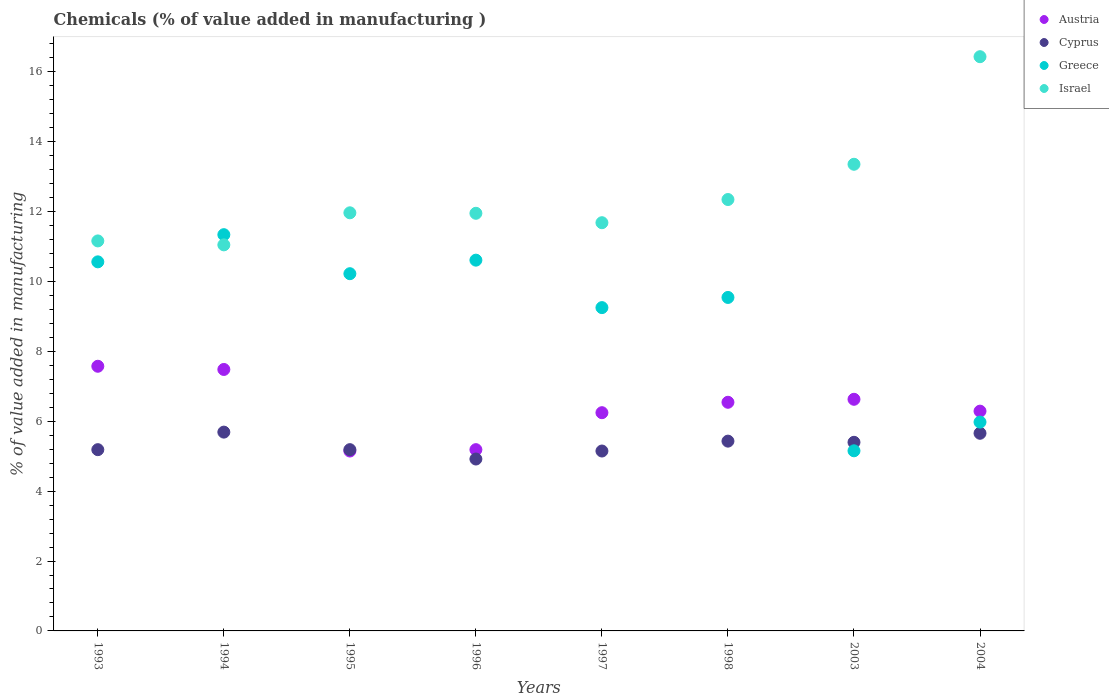How many different coloured dotlines are there?
Provide a succinct answer. 4. Is the number of dotlines equal to the number of legend labels?
Ensure brevity in your answer.  Yes. What is the value added in manufacturing chemicals in Cyprus in 1994?
Give a very brief answer. 5.69. Across all years, what is the maximum value added in manufacturing chemicals in Austria?
Provide a short and direct response. 7.57. Across all years, what is the minimum value added in manufacturing chemicals in Greece?
Your answer should be very brief. 5.16. In which year was the value added in manufacturing chemicals in Austria maximum?
Ensure brevity in your answer.  1993. What is the total value added in manufacturing chemicals in Austria in the graph?
Your answer should be very brief. 51.1. What is the difference between the value added in manufacturing chemicals in Cyprus in 1995 and that in 1998?
Ensure brevity in your answer.  -0.24. What is the difference between the value added in manufacturing chemicals in Austria in 1995 and the value added in manufacturing chemicals in Greece in 1997?
Your response must be concise. -4.1. What is the average value added in manufacturing chemicals in Austria per year?
Your answer should be compact. 6.39. In the year 1995, what is the difference between the value added in manufacturing chemicals in Cyprus and value added in manufacturing chemicals in Greece?
Your answer should be compact. -5.04. What is the ratio of the value added in manufacturing chemicals in Greece in 1997 to that in 2004?
Give a very brief answer. 1.55. Is the difference between the value added in manufacturing chemicals in Cyprus in 1998 and 2003 greater than the difference between the value added in manufacturing chemicals in Greece in 1998 and 2003?
Ensure brevity in your answer.  No. What is the difference between the highest and the second highest value added in manufacturing chemicals in Cyprus?
Ensure brevity in your answer.  0.03. What is the difference between the highest and the lowest value added in manufacturing chemicals in Israel?
Make the answer very short. 5.39. Is the sum of the value added in manufacturing chemicals in Israel in 1995 and 1998 greater than the maximum value added in manufacturing chemicals in Austria across all years?
Provide a succinct answer. Yes. Is it the case that in every year, the sum of the value added in manufacturing chemicals in Israel and value added in manufacturing chemicals in Cyprus  is greater than the value added in manufacturing chemicals in Austria?
Provide a succinct answer. Yes. Does the value added in manufacturing chemicals in Greece monotonically increase over the years?
Ensure brevity in your answer.  No. How many dotlines are there?
Provide a short and direct response. 4. How many years are there in the graph?
Give a very brief answer. 8. Does the graph contain any zero values?
Keep it short and to the point. No. Does the graph contain grids?
Make the answer very short. No. How many legend labels are there?
Make the answer very short. 4. What is the title of the graph?
Give a very brief answer. Chemicals (% of value added in manufacturing ). What is the label or title of the X-axis?
Give a very brief answer. Years. What is the label or title of the Y-axis?
Keep it short and to the point. % of value added in manufacturing. What is the % of value added in manufacturing in Austria in 1993?
Ensure brevity in your answer.  7.57. What is the % of value added in manufacturing in Cyprus in 1993?
Your answer should be very brief. 5.19. What is the % of value added in manufacturing in Greece in 1993?
Provide a succinct answer. 10.56. What is the % of value added in manufacturing of Israel in 1993?
Your answer should be compact. 11.16. What is the % of value added in manufacturing in Austria in 1994?
Your answer should be very brief. 7.48. What is the % of value added in manufacturing of Cyprus in 1994?
Offer a very short reply. 5.69. What is the % of value added in manufacturing in Greece in 1994?
Provide a succinct answer. 11.34. What is the % of value added in manufacturing of Israel in 1994?
Your answer should be compact. 11.05. What is the % of value added in manufacturing of Austria in 1995?
Make the answer very short. 5.15. What is the % of value added in manufacturing in Cyprus in 1995?
Offer a terse response. 5.19. What is the % of value added in manufacturing in Greece in 1995?
Keep it short and to the point. 10.22. What is the % of value added in manufacturing of Israel in 1995?
Keep it short and to the point. 11.97. What is the % of value added in manufacturing in Austria in 1996?
Your answer should be very brief. 5.19. What is the % of value added in manufacturing in Cyprus in 1996?
Provide a succinct answer. 4.92. What is the % of value added in manufacturing in Greece in 1996?
Ensure brevity in your answer.  10.61. What is the % of value added in manufacturing in Israel in 1996?
Ensure brevity in your answer.  11.95. What is the % of value added in manufacturing in Austria in 1997?
Offer a very short reply. 6.25. What is the % of value added in manufacturing in Cyprus in 1997?
Provide a short and direct response. 5.15. What is the % of value added in manufacturing in Greece in 1997?
Ensure brevity in your answer.  9.25. What is the % of value added in manufacturing in Israel in 1997?
Provide a short and direct response. 11.68. What is the % of value added in manufacturing of Austria in 1998?
Provide a short and direct response. 6.54. What is the % of value added in manufacturing in Cyprus in 1998?
Your response must be concise. 5.43. What is the % of value added in manufacturing of Greece in 1998?
Keep it short and to the point. 9.54. What is the % of value added in manufacturing in Israel in 1998?
Give a very brief answer. 12.35. What is the % of value added in manufacturing of Austria in 2003?
Give a very brief answer. 6.63. What is the % of value added in manufacturing in Cyprus in 2003?
Provide a succinct answer. 5.4. What is the % of value added in manufacturing in Greece in 2003?
Your answer should be compact. 5.16. What is the % of value added in manufacturing of Israel in 2003?
Your answer should be compact. 13.36. What is the % of value added in manufacturing in Austria in 2004?
Your answer should be very brief. 6.29. What is the % of value added in manufacturing of Cyprus in 2004?
Ensure brevity in your answer.  5.66. What is the % of value added in manufacturing of Greece in 2004?
Ensure brevity in your answer.  5.98. What is the % of value added in manufacturing in Israel in 2004?
Keep it short and to the point. 16.43. Across all years, what is the maximum % of value added in manufacturing in Austria?
Keep it short and to the point. 7.57. Across all years, what is the maximum % of value added in manufacturing in Cyprus?
Offer a terse response. 5.69. Across all years, what is the maximum % of value added in manufacturing of Greece?
Your answer should be compact. 11.34. Across all years, what is the maximum % of value added in manufacturing of Israel?
Ensure brevity in your answer.  16.43. Across all years, what is the minimum % of value added in manufacturing in Austria?
Your response must be concise. 5.15. Across all years, what is the minimum % of value added in manufacturing of Cyprus?
Keep it short and to the point. 4.92. Across all years, what is the minimum % of value added in manufacturing of Greece?
Your response must be concise. 5.16. Across all years, what is the minimum % of value added in manufacturing of Israel?
Make the answer very short. 11.05. What is the total % of value added in manufacturing in Austria in the graph?
Ensure brevity in your answer.  51.1. What is the total % of value added in manufacturing of Cyprus in the graph?
Provide a short and direct response. 42.62. What is the total % of value added in manufacturing of Greece in the graph?
Offer a terse response. 72.67. What is the total % of value added in manufacturing of Israel in the graph?
Your answer should be compact. 99.95. What is the difference between the % of value added in manufacturing in Austria in 1993 and that in 1994?
Keep it short and to the point. 0.09. What is the difference between the % of value added in manufacturing of Cyprus in 1993 and that in 1994?
Ensure brevity in your answer.  -0.5. What is the difference between the % of value added in manufacturing in Greece in 1993 and that in 1994?
Keep it short and to the point. -0.78. What is the difference between the % of value added in manufacturing of Israel in 1993 and that in 1994?
Make the answer very short. 0.11. What is the difference between the % of value added in manufacturing of Austria in 1993 and that in 1995?
Give a very brief answer. 2.43. What is the difference between the % of value added in manufacturing of Cyprus in 1993 and that in 1995?
Offer a very short reply. -0. What is the difference between the % of value added in manufacturing of Greece in 1993 and that in 1995?
Provide a short and direct response. 0.34. What is the difference between the % of value added in manufacturing of Israel in 1993 and that in 1995?
Offer a terse response. -0.8. What is the difference between the % of value added in manufacturing of Austria in 1993 and that in 1996?
Ensure brevity in your answer.  2.39. What is the difference between the % of value added in manufacturing in Cyprus in 1993 and that in 1996?
Provide a succinct answer. 0.27. What is the difference between the % of value added in manufacturing of Greece in 1993 and that in 1996?
Offer a very short reply. -0.05. What is the difference between the % of value added in manufacturing in Israel in 1993 and that in 1996?
Keep it short and to the point. -0.79. What is the difference between the % of value added in manufacturing of Austria in 1993 and that in 1997?
Offer a very short reply. 1.33. What is the difference between the % of value added in manufacturing in Cyprus in 1993 and that in 1997?
Your answer should be very brief. 0.04. What is the difference between the % of value added in manufacturing of Greece in 1993 and that in 1997?
Keep it short and to the point. 1.31. What is the difference between the % of value added in manufacturing in Israel in 1993 and that in 1997?
Make the answer very short. -0.52. What is the difference between the % of value added in manufacturing of Austria in 1993 and that in 1998?
Your answer should be compact. 1.03. What is the difference between the % of value added in manufacturing of Cyprus in 1993 and that in 1998?
Provide a succinct answer. -0.24. What is the difference between the % of value added in manufacturing of Greece in 1993 and that in 1998?
Give a very brief answer. 1.02. What is the difference between the % of value added in manufacturing in Israel in 1993 and that in 1998?
Your answer should be compact. -1.18. What is the difference between the % of value added in manufacturing in Austria in 1993 and that in 2003?
Your answer should be very brief. 0.95. What is the difference between the % of value added in manufacturing of Cyprus in 1993 and that in 2003?
Make the answer very short. -0.21. What is the difference between the % of value added in manufacturing in Greece in 1993 and that in 2003?
Your response must be concise. 5.41. What is the difference between the % of value added in manufacturing in Israel in 1993 and that in 2003?
Your response must be concise. -2.19. What is the difference between the % of value added in manufacturing in Austria in 1993 and that in 2004?
Provide a short and direct response. 1.28. What is the difference between the % of value added in manufacturing in Cyprus in 1993 and that in 2004?
Make the answer very short. -0.47. What is the difference between the % of value added in manufacturing in Greece in 1993 and that in 2004?
Offer a terse response. 4.59. What is the difference between the % of value added in manufacturing of Israel in 1993 and that in 2004?
Ensure brevity in your answer.  -5.27. What is the difference between the % of value added in manufacturing of Austria in 1994 and that in 1995?
Provide a succinct answer. 2.33. What is the difference between the % of value added in manufacturing in Cyprus in 1994 and that in 1995?
Provide a short and direct response. 0.5. What is the difference between the % of value added in manufacturing of Greece in 1994 and that in 1995?
Your response must be concise. 1.12. What is the difference between the % of value added in manufacturing of Israel in 1994 and that in 1995?
Make the answer very short. -0.92. What is the difference between the % of value added in manufacturing of Austria in 1994 and that in 1996?
Make the answer very short. 2.3. What is the difference between the % of value added in manufacturing of Cyprus in 1994 and that in 1996?
Ensure brevity in your answer.  0.77. What is the difference between the % of value added in manufacturing in Greece in 1994 and that in 1996?
Keep it short and to the point. 0.73. What is the difference between the % of value added in manufacturing of Israel in 1994 and that in 1996?
Keep it short and to the point. -0.9. What is the difference between the % of value added in manufacturing of Austria in 1994 and that in 1997?
Your response must be concise. 1.24. What is the difference between the % of value added in manufacturing of Cyprus in 1994 and that in 1997?
Ensure brevity in your answer.  0.54. What is the difference between the % of value added in manufacturing of Greece in 1994 and that in 1997?
Give a very brief answer. 2.09. What is the difference between the % of value added in manufacturing in Israel in 1994 and that in 1997?
Keep it short and to the point. -0.63. What is the difference between the % of value added in manufacturing in Austria in 1994 and that in 1998?
Your answer should be compact. 0.94. What is the difference between the % of value added in manufacturing of Cyprus in 1994 and that in 1998?
Your response must be concise. 0.26. What is the difference between the % of value added in manufacturing in Greece in 1994 and that in 1998?
Give a very brief answer. 1.8. What is the difference between the % of value added in manufacturing in Israel in 1994 and that in 1998?
Offer a terse response. -1.3. What is the difference between the % of value added in manufacturing of Austria in 1994 and that in 2003?
Keep it short and to the point. 0.85. What is the difference between the % of value added in manufacturing of Cyprus in 1994 and that in 2003?
Provide a short and direct response. 0.29. What is the difference between the % of value added in manufacturing of Greece in 1994 and that in 2003?
Your answer should be compact. 6.19. What is the difference between the % of value added in manufacturing of Israel in 1994 and that in 2003?
Ensure brevity in your answer.  -2.31. What is the difference between the % of value added in manufacturing of Austria in 1994 and that in 2004?
Make the answer very short. 1.19. What is the difference between the % of value added in manufacturing of Cyprus in 1994 and that in 2004?
Provide a succinct answer. 0.03. What is the difference between the % of value added in manufacturing of Greece in 1994 and that in 2004?
Your answer should be compact. 5.36. What is the difference between the % of value added in manufacturing of Israel in 1994 and that in 2004?
Ensure brevity in your answer.  -5.39. What is the difference between the % of value added in manufacturing in Austria in 1995 and that in 1996?
Keep it short and to the point. -0.04. What is the difference between the % of value added in manufacturing in Cyprus in 1995 and that in 1996?
Keep it short and to the point. 0.27. What is the difference between the % of value added in manufacturing in Greece in 1995 and that in 1996?
Offer a terse response. -0.39. What is the difference between the % of value added in manufacturing in Israel in 1995 and that in 1996?
Give a very brief answer. 0.01. What is the difference between the % of value added in manufacturing of Austria in 1995 and that in 1997?
Provide a succinct answer. -1.1. What is the difference between the % of value added in manufacturing of Cyprus in 1995 and that in 1997?
Offer a very short reply. 0.04. What is the difference between the % of value added in manufacturing in Greece in 1995 and that in 1997?
Offer a very short reply. 0.97. What is the difference between the % of value added in manufacturing of Israel in 1995 and that in 1997?
Offer a terse response. 0.28. What is the difference between the % of value added in manufacturing in Austria in 1995 and that in 1998?
Ensure brevity in your answer.  -1.4. What is the difference between the % of value added in manufacturing of Cyprus in 1995 and that in 1998?
Provide a succinct answer. -0.24. What is the difference between the % of value added in manufacturing in Greece in 1995 and that in 1998?
Provide a succinct answer. 0.68. What is the difference between the % of value added in manufacturing of Israel in 1995 and that in 1998?
Ensure brevity in your answer.  -0.38. What is the difference between the % of value added in manufacturing of Austria in 1995 and that in 2003?
Your response must be concise. -1.48. What is the difference between the % of value added in manufacturing in Cyprus in 1995 and that in 2003?
Ensure brevity in your answer.  -0.21. What is the difference between the % of value added in manufacturing of Greece in 1995 and that in 2003?
Offer a terse response. 5.07. What is the difference between the % of value added in manufacturing of Israel in 1995 and that in 2003?
Provide a succinct answer. -1.39. What is the difference between the % of value added in manufacturing of Austria in 1995 and that in 2004?
Your response must be concise. -1.14. What is the difference between the % of value added in manufacturing of Cyprus in 1995 and that in 2004?
Your answer should be compact. -0.47. What is the difference between the % of value added in manufacturing of Greece in 1995 and that in 2004?
Your response must be concise. 4.25. What is the difference between the % of value added in manufacturing of Israel in 1995 and that in 2004?
Ensure brevity in your answer.  -4.47. What is the difference between the % of value added in manufacturing in Austria in 1996 and that in 1997?
Your answer should be compact. -1.06. What is the difference between the % of value added in manufacturing in Cyprus in 1996 and that in 1997?
Ensure brevity in your answer.  -0.23. What is the difference between the % of value added in manufacturing in Greece in 1996 and that in 1997?
Provide a short and direct response. 1.36. What is the difference between the % of value added in manufacturing of Israel in 1996 and that in 1997?
Offer a terse response. 0.27. What is the difference between the % of value added in manufacturing of Austria in 1996 and that in 1998?
Give a very brief answer. -1.36. What is the difference between the % of value added in manufacturing in Cyprus in 1996 and that in 1998?
Ensure brevity in your answer.  -0.51. What is the difference between the % of value added in manufacturing in Greece in 1996 and that in 1998?
Make the answer very short. 1.07. What is the difference between the % of value added in manufacturing in Israel in 1996 and that in 1998?
Your response must be concise. -0.39. What is the difference between the % of value added in manufacturing in Austria in 1996 and that in 2003?
Ensure brevity in your answer.  -1.44. What is the difference between the % of value added in manufacturing in Cyprus in 1996 and that in 2003?
Make the answer very short. -0.48. What is the difference between the % of value added in manufacturing of Greece in 1996 and that in 2003?
Provide a short and direct response. 5.46. What is the difference between the % of value added in manufacturing in Israel in 1996 and that in 2003?
Provide a succinct answer. -1.4. What is the difference between the % of value added in manufacturing in Austria in 1996 and that in 2004?
Provide a short and direct response. -1.1. What is the difference between the % of value added in manufacturing of Cyprus in 1996 and that in 2004?
Make the answer very short. -0.74. What is the difference between the % of value added in manufacturing in Greece in 1996 and that in 2004?
Give a very brief answer. 4.63. What is the difference between the % of value added in manufacturing of Israel in 1996 and that in 2004?
Your answer should be very brief. -4.48. What is the difference between the % of value added in manufacturing in Austria in 1997 and that in 1998?
Your response must be concise. -0.3. What is the difference between the % of value added in manufacturing of Cyprus in 1997 and that in 1998?
Offer a terse response. -0.28. What is the difference between the % of value added in manufacturing of Greece in 1997 and that in 1998?
Your response must be concise. -0.29. What is the difference between the % of value added in manufacturing of Israel in 1997 and that in 1998?
Offer a terse response. -0.66. What is the difference between the % of value added in manufacturing of Austria in 1997 and that in 2003?
Provide a short and direct response. -0.38. What is the difference between the % of value added in manufacturing in Cyprus in 1997 and that in 2003?
Keep it short and to the point. -0.25. What is the difference between the % of value added in manufacturing in Greece in 1997 and that in 2003?
Keep it short and to the point. 4.1. What is the difference between the % of value added in manufacturing of Israel in 1997 and that in 2003?
Provide a short and direct response. -1.67. What is the difference between the % of value added in manufacturing of Austria in 1997 and that in 2004?
Provide a short and direct response. -0.04. What is the difference between the % of value added in manufacturing in Cyprus in 1997 and that in 2004?
Make the answer very short. -0.51. What is the difference between the % of value added in manufacturing of Greece in 1997 and that in 2004?
Give a very brief answer. 3.28. What is the difference between the % of value added in manufacturing in Israel in 1997 and that in 2004?
Make the answer very short. -4.75. What is the difference between the % of value added in manufacturing of Austria in 1998 and that in 2003?
Offer a terse response. -0.09. What is the difference between the % of value added in manufacturing of Cyprus in 1998 and that in 2003?
Offer a very short reply. 0.03. What is the difference between the % of value added in manufacturing in Greece in 1998 and that in 2003?
Give a very brief answer. 4.39. What is the difference between the % of value added in manufacturing of Israel in 1998 and that in 2003?
Provide a succinct answer. -1.01. What is the difference between the % of value added in manufacturing of Austria in 1998 and that in 2004?
Your answer should be very brief. 0.25. What is the difference between the % of value added in manufacturing in Cyprus in 1998 and that in 2004?
Provide a short and direct response. -0.23. What is the difference between the % of value added in manufacturing of Greece in 1998 and that in 2004?
Offer a very short reply. 3.57. What is the difference between the % of value added in manufacturing in Israel in 1998 and that in 2004?
Give a very brief answer. -4.09. What is the difference between the % of value added in manufacturing in Austria in 2003 and that in 2004?
Offer a very short reply. 0.34. What is the difference between the % of value added in manufacturing of Cyprus in 2003 and that in 2004?
Keep it short and to the point. -0.26. What is the difference between the % of value added in manufacturing in Greece in 2003 and that in 2004?
Ensure brevity in your answer.  -0.82. What is the difference between the % of value added in manufacturing of Israel in 2003 and that in 2004?
Your answer should be compact. -3.08. What is the difference between the % of value added in manufacturing in Austria in 1993 and the % of value added in manufacturing in Cyprus in 1994?
Provide a succinct answer. 1.89. What is the difference between the % of value added in manufacturing of Austria in 1993 and the % of value added in manufacturing of Greece in 1994?
Your response must be concise. -3.77. What is the difference between the % of value added in manufacturing of Austria in 1993 and the % of value added in manufacturing of Israel in 1994?
Make the answer very short. -3.47. What is the difference between the % of value added in manufacturing in Cyprus in 1993 and the % of value added in manufacturing in Greece in 1994?
Offer a very short reply. -6.15. What is the difference between the % of value added in manufacturing of Cyprus in 1993 and the % of value added in manufacturing of Israel in 1994?
Offer a terse response. -5.86. What is the difference between the % of value added in manufacturing of Greece in 1993 and the % of value added in manufacturing of Israel in 1994?
Provide a succinct answer. -0.49. What is the difference between the % of value added in manufacturing in Austria in 1993 and the % of value added in manufacturing in Cyprus in 1995?
Your answer should be compact. 2.39. What is the difference between the % of value added in manufacturing of Austria in 1993 and the % of value added in manufacturing of Greece in 1995?
Provide a succinct answer. -2.65. What is the difference between the % of value added in manufacturing in Austria in 1993 and the % of value added in manufacturing in Israel in 1995?
Your answer should be very brief. -4.39. What is the difference between the % of value added in manufacturing of Cyprus in 1993 and the % of value added in manufacturing of Greece in 1995?
Provide a short and direct response. -5.04. What is the difference between the % of value added in manufacturing in Cyprus in 1993 and the % of value added in manufacturing in Israel in 1995?
Provide a short and direct response. -6.78. What is the difference between the % of value added in manufacturing in Greece in 1993 and the % of value added in manufacturing in Israel in 1995?
Make the answer very short. -1.4. What is the difference between the % of value added in manufacturing of Austria in 1993 and the % of value added in manufacturing of Cyprus in 1996?
Your answer should be very brief. 2.65. What is the difference between the % of value added in manufacturing in Austria in 1993 and the % of value added in manufacturing in Greece in 1996?
Ensure brevity in your answer.  -3.04. What is the difference between the % of value added in manufacturing of Austria in 1993 and the % of value added in manufacturing of Israel in 1996?
Provide a succinct answer. -4.38. What is the difference between the % of value added in manufacturing in Cyprus in 1993 and the % of value added in manufacturing in Greece in 1996?
Provide a short and direct response. -5.42. What is the difference between the % of value added in manufacturing of Cyprus in 1993 and the % of value added in manufacturing of Israel in 1996?
Make the answer very short. -6.77. What is the difference between the % of value added in manufacturing of Greece in 1993 and the % of value added in manufacturing of Israel in 1996?
Give a very brief answer. -1.39. What is the difference between the % of value added in manufacturing in Austria in 1993 and the % of value added in manufacturing in Cyprus in 1997?
Give a very brief answer. 2.43. What is the difference between the % of value added in manufacturing of Austria in 1993 and the % of value added in manufacturing of Greece in 1997?
Make the answer very short. -1.68. What is the difference between the % of value added in manufacturing of Austria in 1993 and the % of value added in manufacturing of Israel in 1997?
Provide a short and direct response. -4.11. What is the difference between the % of value added in manufacturing in Cyprus in 1993 and the % of value added in manufacturing in Greece in 1997?
Ensure brevity in your answer.  -4.07. What is the difference between the % of value added in manufacturing in Cyprus in 1993 and the % of value added in manufacturing in Israel in 1997?
Offer a terse response. -6.5. What is the difference between the % of value added in manufacturing of Greece in 1993 and the % of value added in manufacturing of Israel in 1997?
Your response must be concise. -1.12. What is the difference between the % of value added in manufacturing in Austria in 1993 and the % of value added in manufacturing in Cyprus in 1998?
Offer a terse response. 2.14. What is the difference between the % of value added in manufacturing of Austria in 1993 and the % of value added in manufacturing of Greece in 1998?
Your answer should be very brief. -1.97. What is the difference between the % of value added in manufacturing of Austria in 1993 and the % of value added in manufacturing of Israel in 1998?
Your answer should be very brief. -4.77. What is the difference between the % of value added in manufacturing in Cyprus in 1993 and the % of value added in manufacturing in Greece in 1998?
Give a very brief answer. -4.36. What is the difference between the % of value added in manufacturing of Cyprus in 1993 and the % of value added in manufacturing of Israel in 1998?
Keep it short and to the point. -7.16. What is the difference between the % of value added in manufacturing of Greece in 1993 and the % of value added in manufacturing of Israel in 1998?
Offer a very short reply. -1.78. What is the difference between the % of value added in manufacturing in Austria in 1993 and the % of value added in manufacturing in Cyprus in 2003?
Offer a terse response. 2.18. What is the difference between the % of value added in manufacturing in Austria in 1993 and the % of value added in manufacturing in Greece in 2003?
Give a very brief answer. 2.42. What is the difference between the % of value added in manufacturing in Austria in 1993 and the % of value added in manufacturing in Israel in 2003?
Offer a terse response. -5.78. What is the difference between the % of value added in manufacturing in Cyprus in 1993 and the % of value added in manufacturing in Greece in 2003?
Ensure brevity in your answer.  0.03. What is the difference between the % of value added in manufacturing of Cyprus in 1993 and the % of value added in manufacturing of Israel in 2003?
Provide a short and direct response. -8.17. What is the difference between the % of value added in manufacturing in Greece in 1993 and the % of value added in manufacturing in Israel in 2003?
Make the answer very short. -2.79. What is the difference between the % of value added in manufacturing of Austria in 1993 and the % of value added in manufacturing of Cyprus in 2004?
Your response must be concise. 1.92. What is the difference between the % of value added in manufacturing of Austria in 1993 and the % of value added in manufacturing of Greece in 2004?
Provide a succinct answer. 1.6. What is the difference between the % of value added in manufacturing of Austria in 1993 and the % of value added in manufacturing of Israel in 2004?
Offer a very short reply. -8.86. What is the difference between the % of value added in manufacturing of Cyprus in 1993 and the % of value added in manufacturing of Greece in 2004?
Keep it short and to the point. -0.79. What is the difference between the % of value added in manufacturing in Cyprus in 1993 and the % of value added in manufacturing in Israel in 2004?
Your response must be concise. -11.25. What is the difference between the % of value added in manufacturing in Greece in 1993 and the % of value added in manufacturing in Israel in 2004?
Give a very brief answer. -5.87. What is the difference between the % of value added in manufacturing of Austria in 1994 and the % of value added in manufacturing of Cyprus in 1995?
Ensure brevity in your answer.  2.3. What is the difference between the % of value added in manufacturing in Austria in 1994 and the % of value added in manufacturing in Greece in 1995?
Ensure brevity in your answer.  -2.74. What is the difference between the % of value added in manufacturing in Austria in 1994 and the % of value added in manufacturing in Israel in 1995?
Ensure brevity in your answer.  -4.48. What is the difference between the % of value added in manufacturing of Cyprus in 1994 and the % of value added in manufacturing of Greece in 1995?
Make the answer very short. -4.53. What is the difference between the % of value added in manufacturing of Cyprus in 1994 and the % of value added in manufacturing of Israel in 1995?
Make the answer very short. -6.28. What is the difference between the % of value added in manufacturing in Greece in 1994 and the % of value added in manufacturing in Israel in 1995?
Your answer should be compact. -0.63. What is the difference between the % of value added in manufacturing of Austria in 1994 and the % of value added in manufacturing of Cyprus in 1996?
Offer a terse response. 2.56. What is the difference between the % of value added in manufacturing of Austria in 1994 and the % of value added in manufacturing of Greece in 1996?
Your answer should be compact. -3.13. What is the difference between the % of value added in manufacturing in Austria in 1994 and the % of value added in manufacturing in Israel in 1996?
Make the answer very short. -4.47. What is the difference between the % of value added in manufacturing in Cyprus in 1994 and the % of value added in manufacturing in Greece in 1996?
Offer a very short reply. -4.92. What is the difference between the % of value added in manufacturing of Cyprus in 1994 and the % of value added in manufacturing of Israel in 1996?
Offer a very short reply. -6.26. What is the difference between the % of value added in manufacturing of Greece in 1994 and the % of value added in manufacturing of Israel in 1996?
Keep it short and to the point. -0.61. What is the difference between the % of value added in manufacturing in Austria in 1994 and the % of value added in manufacturing in Cyprus in 1997?
Give a very brief answer. 2.33. What is the difference between the % of value added in manufacturing of Austria in 1994 and the % of value added in manufacturing of Greece in 1997?
Provide a succinct answer. -1.77. What is the difference between the % of value added in manufacturing of Austria in 1994 and the % of value added in manufacturing of Israel in 1997?
Your answer should be very brief. -4.2. What is the difference between the % of value added in manufacturing of Cyprus in 1994 and the % of value added in manufacturing of Greece in 1997?
Keep it short and to the point. -3.56. What is the difference between the % of value added in manufacturing of Cyprus in 1994 and the % of value added in manufacturing of Israel in 1997?
Make the answer very short. -5.99. What is the difference between the % of value added in manufacturing in Greece in 1994 and the % of value added in manufacturing in Israel in 1997?
Offer a terse response. -0.34. What is the difference between the % of value added in manufacturing in Austria in 1994 and the % of value added in manufacturing in Cyprus in 1998?
Your answer should be compact. 2.05. What is the difference between the % of value added in manufacturing in Austria in 1994 and the % of value added in manufacturing in Greece in 1998?
Make the answer very short. -2.06. What is the difference between the % of value added in manufacturing in Austria in 1994 and the % of value added in manufacturing in Israel in 1998?
Offer a terse response. -4.86. What is the difference between the % of value added in manufacturing of Cyprus in 1994 and the % of value added in manufacturing of Greece in 1998?
Give a very brief answer. -3.85. What is the difference between the % of value added in manufacturing of Cyprus in 1994 and the % of value added in manufacturing of Israel in 1998?
Your response must be concise. -6.66. What is the difference between the % of value added in manufacturing in Greece in 1994 and the % of value added in manufacturing in Israel in 1998?
Your answer should be very brief. -1.01. What is the difference between the % of value added in manufacturing in Austria in 1994 and the % of value added in manufacturing in Cyprus in 2003?
Offer a terse response. 2.08. What is the difference between the % of value added in manufacturing in Austria in 1994 and the % of value added in manufacturing in Greece in 2003?
Offer a very short reply. 2.33. What is the difference between the % of value added in manufacturing of Austria in 1994 and the % of value added in manufacturing of Israel in 2003?
Offer a very short reply. -5.87. What is the difference between the % of value added in manufacturing of Cyprus in 1994 and the % of value added in manufacturing of Greece in 2003?
Make the answer very short. 0.53. What is the difference between the % of value added in manufacturing in Cyprus in 1994 and the % of value added in manufacturing in Israel in 2003?
Offer a terse response. -7.67. What is the difference between the % of value added in manufacturing in Greece in 1994 and the % of value added in manufacturing in Israel in 2003?
Keep it short and to the point. -2.02. What is the difference between the % of value added in manufacturing in Austria in 1994 and the % of value added in manufacturing in Cyprus in 2004?
Offer a very short reply. 1.83. What is the difference between the % of value added in manufacturing of Austria in 1994 and the % of value added in manufacturing of Greece in 2004?
Ensure brevity in your answer.  1.51. What is the difference between the % of value added in manufacturing in Austria in 1994 and the % of value added in manufacturing in Israel in 2004?
Give a very brief answer. -8.95. What is the difference between the % of value added in manufacturing in Cyprus in 1994 and the % of value added in manufacturing in Greece in 2004?
Offer a very short reply. -0.29. What is the difference between the % of value added in manufacturing in Cyprus in 1994 and the % of value added in manufacturing in Israel in 2004?
Provide a short and direct response. -10.75. What is the difference between the % of value added in manufacturing in Greece in 1994 and the % of value added in manufacturing in Israel in 2004?
Make the answer very short. -5.09. What is the difference between the % of value added in manufacturing in Austria in 1995 and the % of value added in manufacturing in Cyprus in 1996?
Provide a succinct answer. 0.23. What is the difference between the % of value added in manufacturing in Austria in 1995 and the % of value added in manufacturing in Greece in 1996?
Your answer should be very brief. -5.46. What is the difference between the % of value added in manufacturing of Austria in 1995 and the % of value added in manufacturing of Israel in 1996?
Provide a short and direct response. -6.8. What is the difference between the % of value added in manufacturing in Cyprus in 1995 and the % of value added in manufacturing in Greece in 1996?
Ensure brevity in your answer.  -5.42. What is the difference between the % of value added in manufacturing in Cyprus in 1995 and the % of value added in manufacturing in Israel in 1996?
Provide a short and direct response. -6.76. What is the difference between the % of value added in manufacturing in Greece in 1995 and the % of value added in manufacturing in Israel in 1996?
Your response must be concise. -1.73. What is the difference between the % of value added in manufacturing in Austria in 1995 and the % of value added in manufacturing in Cyprus in 1997?
Provide a succinct answer. -0. What is the difference between the % of value added in manufacturing in Austria in 1995 and the % of value added in manufacturing in Greece in 1997?
Your answer should be compact. -4.1. What is the difference between the % of value added in manufacturing in Austria in 1995 and the % of value added in manufacturing in Israel in 1997?
Provide a succinct answer. -6.53. What is the difference between the % of value added in manufacturing of Cyprus in 1995 and the % of value added in manufacturing of Greece in 1997?
Give a very brief answer. -4.07. What is the difference between the % of value added in manufacturing in Cyprus in 1995 and the % of value added in manufacturing in Israel in 1997?
Provide a succinct answer. -6.5. What is the difference between the % of value added in manufacturing of Greece in 1995 and the % of value added in manufacturing of Israel in 1997?
Give a very brief answer. -1.46. What is the difference between the % of value added in manufacturing in Austria in 1995 and the % of value added in manufacturing in Cyprus in 1998?
Give a very brief answer. -0.28. What is the difference between the % of value added in manufacturing of Austria in 1995 and the % of value added in manufacturing of Greece in 1998?
Ensure brevity in your answer.  -4.4. What is the difference between the % of value added in manufacturing of Austria in 1995 and the % of value added in manufacturing of Israel in 1998?
Your response must be concise. -7.2. What is the difference between the % of value added in manufacturing of Cyprus in 1995 and the % of value added in manufacturing of Greece in 1998?
Give a very brief answer. -4.36. What is the difference between the % of value added in manufacturing in Cyprus in 1995 and the % of value added in manufacturing in Israel in 1998?
Provide a succinct answer. -7.16. What is the difference between the % of value added in manufacturing of Greece in 1995 and the % of value added in manufacturing of Israel in 1998?
Provide a short and direct response. -2.12. What is the difference between the % of value added in manufacturing in Austria in 1995 and the % of value added in manufacturing in Cyprus in 2003?
Your response must be concise. -0.25. What is the difference between the % of value added in manufacturing in Austria in 1995 and the % of value added in manufacturing in Greece in 2003?
Offer a very short reply. -0.01. What is the difference between the % of value added in manufacturing of Austria in 1995 and the % of value added in manufacturing of Israel in 2003?
Your answer should be very brief. -8.21. What is the difference between the % of value added in manufacturing of Cyprus in 1995 and the % of value added in manufacturing of Greece in 2003?
Give a very brief answer. 0.03. What is the difference between the % of value added in manufacturing of Cyprus in 1995 and the % of value added in manufacturing of Israel in 2003?
Ensure brevity in your answer.  -8.17. What is the difference between the % of value added in manufacturing in Greece in 1995 and the % of value added in manufacturing in Israel in 2003?
Your response must be concise. -3.13. What is the difference between the % of value added in manufacturing of Austria in 1995 and the % of value added in manufacturing of Cyprus in 2004?
Offer a very short reply. -0.51. What is the difference between the % of value added in manufacturing of Austria in 1995 and the % of value added in manufacturing of Greece in 2004?
Offer a very short reply. -0.83. What is the difference between the % of value added in manufacturing of Austria in 1995 and the % of value added in manufacturing of Israel in 2004?
Keep it short and to the point. -11.29. What is the difference between the % of value added in manufacturing of Cyprus in 1995 and the % of value added in manufacturing of Greece in 2004?
Your response must be concise. -0.79. What is the difference between the % of value added in manufacturing of Cyprus in 1995 and the % of value added in manufacturing of Israel in 2004?
Your answer should be compact. -11.25. What is the difference between the % of value added in manufacturing in Greece in 1995 and the % of value added in manufacturing in Israel in 2004?
Offer a terse response. -6.21. What is the difference between the % of value added in manufacturing in Austria in 1996 and the % of value added in manufacturing in Cyprus in 1997?
Your response must be concise. 0.04. What is the difference between the % of value added in manufacturing in Austria in 1996 and the % of value added in manufacturing in Greece in 1997?
Your answer should be compact. -4.07. What is the difference between the % of value added in manufacturing in Austria in 1996 and the % of value added in manufacturing in Israel in 1997?
Make the answer very short. -6.5. What is the difference between the % of value added in manufacturing in Cyprus in 1996 and the % of value added in manufacturing in Greece in 1997?
Your answer should be compact. -4.33. What is the difference between the % of value added in manufacturing of Cyprus in 1996 and the % of value added in manufacturing of Israel in 1997?
Provide a short and direct response. -6.76. What is the difference between the % of value added in manufacturing in Greece in 1996 and the % of value added in manufacturing in Israel in 1997?
Your answer should be compact. -1.07. What is the difference between the % of value added in manufacturing in Austria in 1996 and the % of value added in manufacturing in Cyprus in 1998?
Provide a short and direct response. -0.24. What is the difference between the % of value added in manufacturing in Austria in 1996 and the % of value added in manufacturing in Greece in 1998?
Ensure brevity in your answer.  -4.36. What is the difference between the % of value added in manufacturing in Austria in 1996 and the % of value added in manufacturing in Israel in 1998?
Provide a succinct answer. -7.16. What is the difference between the % of value added in manufacturing in Cyprus in 1996 and the % of value added in manufacturing in Greece in 1998?
Ensure brevity in your answer.  -4.62. What is the difference between the % of value added in manufacturing in Cyprus in 1996 and the % of value added in manufacturing in Israel in 1998?
Offer a terse response. -7.43. What is the difference between the % of value added in manufacturing of Greece in 1996 and the % of value added in manufacturing of Israel in 1998?
Give a very brief answer. -1.74. What is the difference between the % of value added in manufacturing of Austria in 1996 and the % of value added in manufacturing of Cyprus in 2003?
Your response must be concise. -0.21. What is the difference between the % of value added in manufacturing of Austria in 1996 and the % of value added in manufacturing of Greece in 2003?
Offer a terse response. 0.03. What is the difference between the % of value added in manufacturing in Austria in 1996 and the % of value added in manufacturing in Israel in 2003?
Make the answer very short. -8.17. What is the difference between the % of value added in manufacturing of Cyprus in 1996 and the % of value added in manufacturing of Greece in 2003?
Provide a short and direct response. -0.24. What is the difference between the % of value added in manufacturing in Cyprus in 1996 and the % of value added in manufacturing in Israel in 2003?
Offer a terse response. -8.44. What is the difference between the % of value added in manufacturing in Greece in 1996 and the % of value added in manufacturing in Israel in 2003?
Offer a very short reply. -2.74. What is the difference between the % of value added in manufacturing of Austria in 1996 and the % of value added in manufacturing of Cyprus in 2004?
Your response must be concise. -0.47. What is the difference between the % of value added in manufacturing in Austria in 1996 and the % of value added in manufacturing in Greece in 2004?
Keep it short and to the point. -0.79. What is the difference between the % of value added in manufacturing in Austria in 1996 and the % of value added in manufacturing in Israel in 2004?
Offer a very short reply. -11.25. What is the difference between the % of value added in manufacturing in Cyprus in 1996 and the % of value added in manufacturing in Greece in 2004?
Your response must be concise. -1.06. What is the difference between the % of value added in manufacturing of Cyprus in 1996 and the % of value added in manufacturing of Israel in 2004?
Ensure brevity in your answer.  -11.51. What is the difference between the % of value added in manufacturing in Greece in 1996 and the % of value added in manufacturing in Israel in 2004?
Provide a short and direct response. -5.82. What is the difference between the % of value added in manufacturing in Austria in 1997 and the % of value added in manufacturing in Cyprus in 1998?
Ensure brevity in your answer.  0.81. What is the difference between the % of value added in manufacturing in Austria in 1997 and the % of value added in manufacturing in Greece in 1998?
Ensure brevity in your answer.  -3.3. What is the difference between the % of value added in manufacturing of Austria in 1997 and the % of value added in manufacturing of Israel in 1998?
Give a very brief answer. -6.1. What is the difference between the % of value added in manufacturing in Cyprus in 1997 and the % of value added in manufacturing in Greece in 1998?
Ensure brevity in your answer.  -4.4. What is the difference between the % of value added in manufacturing of Cyprus in 1997 and the % of value added in manufacturing of Israel in 1998?
Your answer should be very brief. -7.2. What is the difference between the % of value added in manufacturing of Greece in 1997 and the % of value added in manufacturing of Israel in 1998?
Offer a very short reply. -3.09. What is the difference between the % of value added in manufacturing of Austria in 1997 and the % of value added in manufacturing of Cyprus in 2003?
Make the answer very short. 0.85. What is the difference between the % of value added in manufacturing of Austria in 1997 and the % of value added in manufacturing of Greece in 2003?
Your response must be concise. 1.09. What is the difference between the % of value added in manufacturing in Austria in 1997 and the % of value added in manufacturing in Israel in 2003?
Offer a very short reply. -7.11. What is the difference between the % of value added in manufacturing in Cyprus in 1997 and the % of value added in manufacturing in Greece in 2003?
Keep it short and to the point. -0.01. What is the difference between the % of value added in manufacturing in Cyprus in 1997 and the % of value added in manufacturing in Israel in 2003?
Offer a very short reply. -8.21. What is the difference between the % of value added in manufacturing of Greece in 1997 and the % of value added in manufacturing of Israel in 2003?
Provide a succinct answer. -4.1. What is the difference between the % of value added in manufacturing in Austria in 1997 and the % of value added in manufacturing in Cyprus in 2004?
Ensure brevity in your answer.  0.59. What is the difference between the % of value added in manufacturing in Austria in 1997 and the % of value added in manufacturing in Greece in 2004?
Offer a terse response. 0.27. What is the difference between the % of value added in manufacturing in Austria in 1997 and the % of value added in manufacturing in Israel in 2004?
Ensure brevity in your answer.  -10.19. What is the difference between the % of value added in manufacturing in Cyprus in 1997 and the % of value added in manufacturing in Greece in 2004?
Offer a very short reply. -0.83. What is the difference between the % of value added in manufacturing of Cyprus in 1997 and the % of value added in manufacturing of Israel in 2004?
Offer a terse response. -11.29. What is the difference between the % of value added in manufacturing of Greece in 1997 and the % of value added in manufacturing of Israel in 2004?
Your answer should be compact. -7.18. What is the difference between the % of value added in manufacturing in Austria in 1998 and the % of value added in manufacturing in Cyprus in 2003?
Your answer should be very brief. 1.15. What is the difference between the % of value added in manufacturing of Austria in 1998 and the % of value added in manufacturing of Greece in 2003?
Offer a terse response. 1.39. What is the difference between the % of value added in manufacturing of Austria in 1998 and the % of value added in manufacturing of Israel in 2003?
Your response must be concise. -6.81. What is the difference between the % of value added in manufacturing in Cyprus in 1998 and the % of value added in manufacturing in Greece in 2003?
Provide a short and direct response. 0.28. What is the difference between the % of value added in manufacturing of Cyprus in 1998 and the % of value added in manufacturing of Israel in 2003?
Provide a short and direct response. -7.92. What is the difference between the % of value added in manufacturing of Greece in 1998 and the % of value added in manufacturing of Israel in 2003?
Your answer should be compact. -3.81. What is the difference between the % of value added in manufacturing in Austria in 1998 and the % of value added in manufacturing in Cyprus in 2004?
Offer a very short reply. 0.89. What is the difference between the % of value added in manufacturing of Austria in 1998 and the % of value added in manufacturing of Greece in 2004?
Provide a short and direct response. 0.57. What is the difference between the % of value added in manufacturing in Austria in 1998 and the % of value added in manufacturing in Israel in 2004?
Ensure brevity in your answer.  -9.89. What is the difference between the % of value added in manufacturing in Cyprus in 1998 and the % of value added in manufacturing in Greece in 2004?
Offer a terse response. -0.55. What is the difference between the % of value added in manufacturing in Cyprus in 1998 and the % of value added in manufacturing in Israel in 2004?
Your answer should be very brief. -11. What is the difference between the % of value added in manufacturing in Greece in 1998 and the % of value added in manufacturing in Israel in 2004?
Provide a succinct answer. -6.89. What is the difference between the % of value added in manufacturing of Austria in 2003 and the % of value added in manufacturing of Cyprus in 2004?
Offer a very short reply. 0.97. What is the difference between the % of value added in manufacturing of Austria in 2003 and the % of value added in manufacturing of Greece in 2004?
Your answer should be very brief. 0.65. What is the difference between the % of value added in manufacturing of Austria in 2003 and the % of value added in manufacturing of Israel in 2004?
Provide a succinct answer. -9.81. What is the difference between the % of value added in manufacturing of Cyprus in 2003 and the % of value added in manufacturing of Greece in 2004?
Make the answer very short. -0.58. What is the difference between the % of value added in manufacturing in Cyprus in 2003 and the % of value added in manufacturing in Israel in 2004?
Your answer should be compact. -11.04. What is the difference between the % of value added in manufacturing of Greece in 2003 and the % of value added in manufacturing of Israel in 2004?
Ensure brevity in your answer.  -11.28. What is the average % of value added in manufacturing in Austria per year?
Offer a very short reply. 6.39. What is the average % of value added in manufacturing in Cyprus per year?
Make the answer very short. 5.33. What is the average % of value added in manufacturing of Greece per year?
Give a very brief answer. 9.08. What is the average % of value added in manufacturing in Israel per year?
Provide a succinct answer. 12.49. In the year 1993, what is the difference between the % of value added in manufacturing of Austria and % of value added in manufacturing of Cyprus?
Your answer should be very brief. 2.39. In the year 1993, what is the difference between the % of value added in manufacturing in Austria and % of value added in manufacturing in Greece?
Give a very brief answer. -2.99. In the year 1993, what is the difference between the % of value added in manufacturing of Austria and % of value added in manufacturing of Israel?
Give a very brief answer. -3.59. In the year 1993, what is the difference between the % of value added in manufacturing of Cyprus and % of value added in manufacturing of Greece?
Provide a succinct answer. -5.38. In the year 1993, what is the difference between the % of value added in manufacturing of Cyprus and % of value added in manufacturing of Israel?
Provide a short and direct response. -5.97. In the year 1993, what is the difference between the % of value added in manufacturing of Greece and % of value added in manufacturing of Israel?
Keep it short and to the point. -0.6. In the year 1994, what is the difference between the % of value added in manufacturing in Austria and % of value added in manufacturing in Cyprus?
Give a very brief answer. 1.79. In the year 1994, what is the difference between the % of value added in manufacturing in Austria and % of value added in manufacturing in Greece?
Make the answer very short. -3.86. In the year 1994, what is the difference between the % of value added in manufacturing of Austria and % of value added in manufacturing of Israel?
Your response must be concise. -3.57. In the year 1994, what is the difference between the % of value added in manufacturing in Cyprus and % of value added in manufacturing in Greece?
Your answer should be compact. -5.65. In the year 1994, what is the difference between the % of value added in manufacturing of Cyprus and % of value added in manufacturing of Israel?
Make the answer very short. -5.36. In the year 1994, what is the difference between the % of value added in manufacturing in Greece and % of value added in manufacturing in Israel?
Provide a short and direct response. 0.29. In the year 1995, what is the difference between the % of value added in manufacturing of Austria and % of value added in manufacturing of Cyprus?
Your answer should be compact. -0.04. In the year 1995, what is the difference between the % of value added in manufacturing in Austria and % of value added in manufacturing in Greece?
Your answer should be very brief. -5.08. In the year 1995, what is the difference between the % of value added in manufacturing in Austria and % of value added in manufacturing in Israel?
Provide a succinct answer. -6.82. In the year 1995, what is the difference between the % of value added in manufacturing of Cyprus and % of value added in manufacturing of Greece?
Offer a very short reply. -5.04. In the year 1995, what is the difference between the % of value added in manufacturing in Cyprus and % of value added in manufacturing in Israel?
Provide a succinct answer. -6.78. In the year 1995, what is the difference between the % of value added in manufacturing of Greece and % of value added in manufacturing of Israel?
Your answer should be compact. -1.74. In the year 1996, what is the difference between the % of value added in manufacturing of Austria and % of value added in manufacturing of Cyprus?
Ensure brevity in your answer.  0.27. In the year 1996, what is the difference between the % of value added in manufacturing in Austria and % of value added in manufacturing in Greece?
Provide a succinct answer. -5.42. In the year 1996, what is the difference between the % of value added in manufacturing of Austria and % of value added in manufacturing of Israel?
Your response must be concise. -6.76. In the year 1996, what is the difference between the % of value added in manufacturing of Cyprus and % of value added in manufacturing of Greece?
Keep it short and to the point. -5.69. In the year 1996, what is the difference between the % of value added in manufacturing of Cyprus and % of value added in manufacturing of Israel?
Ensure brevity in your answer.  -7.03. In the year 1996, what is the difference between the % of value added in manufacturing in Greece and % of value added in manufacturing in Israel?
Make the answer very short. -1.34. In the year 1997, what is the difference between the % of value added in manufacturing of Austria and % of value added in manufacturing of Cyprus?
Provide a short and direct response. 1.1. In the year 1997, what is the difference between the % of value added in manufacturing of Austria and % of value added in manufacturing of Greece?
Provide a succinct answer. -3.01. In the year 1997, what is the difference between the % of value added in manufacturing of Austria and % of value added in manufacturing of Israel?
Make the answer very short. -5.44. In the year 1997, what is the difference between the % of value added in manufacturing in Cyprus and % of value added in manufacturing in Greece?
Your response must be concise. -4.1. In the year 1997, what is the difference between the % of value added in manufacturing in Cyprus and % of value added in manufacturing in Israel?
Provide a succinct answer. -6.53. In the year 1997, what is the difference between the % of value added in manufacturing of Greece and % of value added in manufacturing of Israel?
Offer a very short reply. -2.43. In the year 1998, what is the difference between the % of value added in manufacturing of Austria and % of value added in manufacturing of Cyprus?
Offer a very short reply. 1.11. In the year 1998, what is the difference between the % of value added in manufacturing in Austria and % of value added in manufacturing in Greece?
Give a very brief answer. -3. In the year 1998, what is the difference between the % of value added in manufacturing in Austria and % of value added in manufacturing in Israel?
Ensure brevity in your answer.  -5.8. In the year 1998, what is the difference between the % of value added in manufacturing in Cyprus and % of value added in manufacturing in Greece?
Offer a terse response. -4.11. In the year 1998, what is the difference between the % of value added in manufacturing in Cyprus and % of value added in manufacturing in Israel?
Your response must be concise. -6.92. In the year 1998, what is the difference between the % of value added in manufacturing of Greece and % of value added in manufacturing of Israel?
Your answer should be compact. -2.8. In the year 2003, what is the difference between the % of value added in manufacturing of Austria and % of value added in manufacturing of Cyprus?
Make the answer very short. 1.23. In the year 2003, what is the difference between the % of value added in manufacturing of Austria and % of value added in manufacturing of Greece?
Provide a succinct answer. 1.47. In the year 2003, what is the difference between the % of value added in manufacturing of Austria and % of value added in manufacturing of Israel?
Your answer should be compact. -6.73. In the year 2003, what is the difference between the % of value added in manufacturing in Cyprus and % of value added in manufacturing in Greece?
Your answer should be very brief. 0.24. In the year 2003, what is the difference between the % of value added in manufacturing in Cyprus and % of value added in manufacturing in Israel?
Make the answer very short. -7.96. In the year 2003, what is the difference between the % of value added in manufacturing in Greece and % of value added in manufacturing in Israel?
Offer a terse response. -8.2. In the year 2004, what is the difference between the % of value added in manufacturing of Austria and % of value added in manufacturing of Cyprus?
Your response must be concise. 0.63. In the year 2004, what is the difference between the % of value added in manufacturing of Austria and % of value added in manufacturing of Greece?
Keep it short and to the point. 0.31. In the year 2004, what is the difference between the % of value added in manufacturing of Austria and % of value added in manufacturing of Israel?
Ensure brevity in your answer.  -10.14. In the year 2004, what is the difference between the % of value added in manufacturing of Cyprus and % of value added in manufacturing of Greece?
Offer a very short reply. -0.32. In the year 2004, what is the difference between the % of value added in manufacturing of Cyprus and % of value added in manufacturing of Israel?
Your answer should be very brief. -10.78. In the year 2004, what is the difference between the % of value added in manufacturing in Greece and % of value added in manufacturing in Israel?
Provide a short and direct response. -10.46. What is the ratio of the % of value added in manufacturing of Austria in 1993 to that in 1994?
Your response must be concise. 1.01. What is the ratio of the % of value added in manufacturing in Cyprus in 1993 to that in 1994?
Your answer should be compact. 0.91. What is the ratio of the % of value added in manufacturing of Greece in 1993 to that in 1994?
Ensure brevity in your answer.  0.93. What is the ratio of the % of value added in manufacturing of Israel in 1993 to that in 1994?
Offer a very short reply. 1.01. What is the ratio of the % of value added in manufacturing of Austria in 1993 to that in 1995?
Provide a short and direct response. 1.47. What is the ratio of the % of value added in manufacturing in Cyprus in 1993 to that in 1995?
Make the answer very short. 1. What is the ratio of the % of value added in manufacturing in Greece in 1993 to that in 1995?
Offer a terse response. 1.03. What is the ratio of the % of value added in manufacturing in Israel in 1993 to that in 1995?
Keep it short and to the point. 0.93. What is the ratio of the % of value added in manufacturing of Austria in 1993 to that in 1996?
Your answer should be very brief. 1.46. What is the ratio of the % of value added in manufacturing of Cyprus in 1993 to that in 1996?
Your answer should be compact. 1.05. What is the ratio of the % of value added in manufacturing of Israel in 1993 to that in 1996?
Provide a succinct answer. 0.93. What is the ratio of the % of value added in manufacturing in Austria in 1993 to that in 1997?
Offer a very short reply. 1.21. What is the ratio of the % of value added in manufacturing of Cyprus in 1993 to that in 1997?
Offer a very short reply. 1.01. What is the ratio of the % of value added in manufacturing in Greece in 1993 to that in 1997?
Make the answer very short. 1.14. What is the ratio of the % of value added in manufacturing of Israel in 1993 to that in 1997?
Ensure brevity in your answer.  0.96. What is the ratio of the % of value added in manufacturing in Austria in 1993 to that in 1998?
Your answer should be compact. 1.16. What is the ratio of the % of value added in manufacturing in Cyprus in 1993 to that in 1998?
Offer a terse response. 0.95. What is the ratio of the % of value added in manufacturing of Greece in 1993 to that in 1998?
Ensure brevity in your answer.  1.11. What is the ratio of the % of value added in manufacturing in Israel in 1993 to that in 1998?
Your answer should be very brief. 0.9. What is the ratio of the % of value added in manufacturing of Austria in 1993 to that in 2003?
Give a very brief answer. 1.14. What is the ratio of the % of value added in manufacturing in Greece in 1993 to that in 2003?
Provide a succinct answer. 2.05. What is the ratio of the % of value added in manufacturing of Israel in 1993 to that in 2003?
Ensure brevity in your answer.  0.84. What is the ratio of the % of value added in manufacturing in Austria in 1993 to that in 2004?
Make the answer very short. 1.2. What is the ratio of the % of value added in manufacturing of Cyprus in 1993 to that in 2004?
Your response must be concise. 0.92. What is the ratio of the % of value added in manufacturing of Greece in 1993 to that in 2004?
Provide a short and direct response. 1.77. What is the ratio of the % of value added in manufacturing of Israel in 1993 to that in 2004?
Offer a terse response. 0.68. What is the ratio of the % of value added in manufacturing of Austria in 1994 to that in 1995?
Give a very brief answer. 1.45. What is the ratio of the % of value added in manufacturing of Cyprus in 1994 to that in 1995?
Ensure brevity in your answer.  1.1. What is the ratio of the % of value added in manufacturing in Greece in 1994 to that in 1995?
Give a very brief answer. 1.11. What is the ratio of the % of value added in manufacturing in Israel in 1994 to that in 1995?
Your answer should be very brief. 0.92. What is the ratio of the % of value added in manufacturing in Austria in 1994 to that in 1996?
Your answer should be compact. 1.44. What is the ratio of the % of value added in manufacturing in Cyprus in 1994 to that in 1996?
Your response must be concise. 1.16. What is the ratio of the % of value added in manufacturing in Greece in 1994 to that in 1996?
Keep it short and to the point. 1.07. What is the ratio of the % of value added in manufacturing of Israel in 1994 to that in 1996?
Ensure brevity in your answer.  0.92. What is the ratio of the % of value added in manufacturing in Austria in 1994 to that in 1997?
Ensure brevity in your answer.  1.2. What is the ratio of the % of value added in manufacturing of Cyprus in 1994 to that in 1997?
Offer a terse response. 1.1. What is the ratio of the % of value added in manufacturing of Greece in 1994 to that in 1997?
Your response must be concise. 1.23. What is the ratio of the % of value added in manufacturing of Israel in 1994 to that in 1997?
Offer a terse response. 0.95. What is the ratio of the % of value added in manufacturing in Austria in 1994 to that in 1998?
Offer a very short reply. 1.14. What is the ratio of the % of value added in manufacturing of Cyprus in 1994 to that in 1998?
Offer a very short reply. 1.05. What is the ratio of the % of value added in manufacturing of Greece in 1994 to that in 1998?
Keep it short and to the point. 1.19. What is the ratio of the % of value added in manufacturing in Israel in 1994 to that in 1998?
Offer a terse response. 0.89. What is the ratio of the % of value added in manufacturing of Austria in 1994 to that in 2003?
Ensure brevity in your answer.  1.13. What is the ratio of the % of value added in manufacturing of Cyprus in 1994 to that in 2003?
Make the answer very short. 1.05. What is the ratio of the % of value added in manufacturing of Greece in 1994 to that in 2003?
Provide a short and direct response. 2.2. What is the ratio of the % of value added in manufacturing in Israel in 1994 to that in 2003?
Make the answer very short. 0.83. What is the ratio of the % of value added in manufacturing in Austria in 1994 to that in 2004?
Ensure brevity in your answer.  1.19. What is the ratio of the % of value added in manufacturing of Greece in 1994 to that in 2004?
Your response must be concise. 1.9. What is the ratio of the % of value added in manufacturing in Israel in 1994 to that in 2004?
Provide a succinct answer. 0.67. What is the ratio of the % of value added in manufacturing in Austria in 1995 to that in 1996?
Provide a short and direct response. 0.99. What is the ratio of the % of value added in manufacturing of Cyprus in 1995 to that in 1996?
Offer a terse response. 1.05. What is the ratio of the % of value added in manufacturing in Greece in 1995 to that in 1996?
Make the answer very short. 0.96. What is the ratio of the % of value added in manufacturing of Israel in 1995 to that in 1996?
Provide a short and direct response. 1. What is the ratio of the % of value added in manufacturing of Austria in 1995 to that in 1997?
Ensure brevity in your answer.  0.82. What is the ratio of the % of value added in manufacturing of Cyprus in 1995 to that in 1997?
Your answer should be compact. 1.01. What is the ratio of the % of value added in manufacturing of Greece in 1995 to that in 1997?
Your response must be concise. 1.1. What is the ratio of the % of value added in manufacturing of Israel in 1995 to that in 1997?
Keep it short and to the point. 1.02. What is the ratio of the % of value added in manufacturing of Austria in 1995 to that in 1998?
Ensure brevity in your answer.  0.79. What is the ratio of the % of value added in manufacturing of Cyprus in 1995 to that in 1998?
Ensure brevity in your answer.  0.96. What is the ratio of the % of value added in manufacturing of Greece in 1995 to that in 1998?
Provide a succinct answer. 1.07. What is the ratio of the % of value added in manufacturing of Israel in 1995 to that in 1998?
Your response must be concise. 0.97. What is the ratio of the % of value added in manufacturing of Austria in 1995 to that in 2003?
Provide a succinct answer. 0.78. What is the ratio of the % of value added in manufacturing in Cyprus in 1995 to that in 2003?
Give a very brief answer. 0.96. What is the ratio of the % of value added in manufacturing in Greece in 1995 to that in 2003?
Your answer should be very brief. 1.98. What is the ratio of the % of value added in manufacturing in Israel in 1995 to that in 2003?
Make the answer very short. 0.9. What is the ratio of the % of value added in manufacturing of Austria in 1995 to that in 2004?
Your response must be concise. 0.82. What is the ratio of the % of value added in manufacturing of Cyprus in 1995 to that in 2004?
Ensure brevity in your answer.  0.92. What is the ratio of the % of value added in manufacturing of Greece in 1995 to that in 2004?
Provide a succinct answer. 1.71. What is the ratio of the % of value added in manufacturing of Israel in 1995 to that in 2004?
Offer a very short reply. 0.73. What is the ratio of the % of value added in manufacturing of Austria in 1996 to that in 1997?
Keep it short and to the point. 0.83. What is the ratio of the % of value added in manufacturing in Cyprus in 1996 to that in 1997?
Give a very brief answer. 0.96. What is the ratio of the % of value added in manufacturing of Greece in 1996 to that in 1997?
Provide a short and direct response. 1.15. What is the ratio of the % of value added in manufacturing of Israel in 1996 to that in 1997?
Offer a very short reply. 1.02. What is the ratio of the % of value added in manufacturing in Austria in 1996 to that in 1998?
Your answer should be compact. 0.79. What is the ratio of the % of value added in manufacturing in Cyprus in 1996 to that in 1998?
Your response must be concise. 0.91. What is the ratio of the % of value added in manufacturing of Greece in 1996 to that in 1998?
Offer a very short reply. 1.11. What is the ratio of the % of value added in manufacturing of Israel in 1996 to that in 1998?
Your answer should be compact. 0.97. What is the ratio of the % of value added in manufacturing in Austria in 1996 to that in 2003?
Make the answer very short. 0.78. What is the ratio of the % of value added in manufacturing of Cyprus in 1996 to that in 2003?
Keep it short and to the point. 0.91. What is the ratio of the % of value added in manufacturing of Greece in 1996 to that in 2003?
Your response must be concise. 2.06. What is the ratio of the % of value added in manufacturing of Israel in 1996 to that in 2003?
Give a very brief answer. 0.89. What is the ratio of the % of value added in manufacturing in Austria in 1996 to that in 2004?
Your answer should be compact. 0.82. What is the ratio of the % of value added in manufacturing in Cyprus in 1996 to that in 2004?
Ensure brevity in your answer.  0.87. What is the ratio of the % of value added in manufacturing in Greece in 1996 to that in 2004?
Give a very brief answer. 1.78. What is the ratio of the % of value added in manufacturing of Israel in 1996 to that in 2004?
Give a very brief answer. 0.73. What is the ratio of the % of value added in manufacturing in Austria in 1997 to that in 1998?
Provide a short and direct response. 0.95. What is the ratio of the % of value added in manufacturing of Cyprus in 1997 to that in 1998?
Provide a succinct answer. 0.95. What is the ratio of the % of value added in manufacturing of Greece in 1997 to that in 1998?
Your response must be concise. 0.97. What is the ratio of the % of value added in manufacturing in Israel in 1997 to that in 1998?
Offer a terse response. 0.95. What is the ratio of the % of value added in manufacturing in Austria in 1997 to that in 2003?
Make the answer very short. 0.94. What is the ratio of the % of value added in manufacturing of Cyprus in 1997 to that in 2003?
Make the answer very short. 0.95. What is the ratio of the % of value added in manufacturing in Greece in 1997 to that in 2003?
Provide a short and direct response. 1.79. What is the ratio of the % of value added in manufacturing in Israel in 1997 to that in 2003?
Give a very brief answer. 0.87. What is the ratio of the % of value added in manufacturing of Austria in 1997 to that in 2004?
Your answer should be compact. 0.99. What is the ratio of the % of value added in manufacturing of Cyprus in 1997 to that in 2004?
Your response must be concise. 0.91. What is the ratio of the % of value added in manufacturing of Greece in 1997 to that in 2004?
Offer a very short reply. 1.55. What is the ratio of the % of value added in manufacturing in Israel in 1997 to that in 2004?
Give a very brief answer. 0.71. What is the ratio of the % of value added in manufacturing of Austria in 1998 to that in 2003?
Provide a succinct answer. 0.99. What is the ratio of the % of value added in manufacturing of Greece in 1998 to that in 2003?
Offer a very short reply. 1.85. What is the ratio of the % of value added in manufacturing in Israel in 1998 to that in 2003?
Ensure brevity in your answer.  0.92. What is the ratio of the % of value added in manufacturing of Austria in 1998 to that in 2004?
Make the answer very short. 1.04. What is the ratio of the % of value added in manufacturing in Cyprus in 1998 to that in 2004?
Provide a succinct answer. 0.96. What is the ratio of the % of value added in manufacturing in Greece in 1998 to that in 2004?
Give a very brief answer. 1.6. What is the ratio of the % of value added in manufacturing in Israel in 1998 to that in 2004?
Your answer should be compact. 0.75. What is the ratio of the % of value added in manufacturing in Austria in 2003 to that in 2004?
Give a very brief answer. 1.05. What is the ratio of the % of value added in manufacturing of Cyprus in 2003 to that in 2004?
Offer a terse response. 0.95. What is the ratio of the % of value added in manufacturing of Greece in 2003 to that in 2004?
Offer a very short reply. 0.86. What is the ratio of the % of value added in manufacturing of Israel in 2003 to that in 2004?
Ensure brevity in your answer.  0.81. What is the difference between the highest and the second highest % of value added in manufacturing of Austria?
Provide a succinct answer. 0.09. What is the difference between the highest and the second highest % of value added in manufacturing in Cyprus?
Provide a succinct answer. 0.03. What is the difference between the highest and the second highest % of value added in manufacturing of Greece?
Give a very brief answer. 0.73. What is the difference between the highest and the second highest % of value added in manufacturing of Israel?
Keep it short and to the point. 3.08. What is the difference between the highest and the lowest % of value added in manufacturing of Austria?
Your response must be concise. 2.43. What is the difference between the highest and the lowest % of value added in manufacturing of Cyprus?
Your answer should be very brief. 0.77. What is the difference between the highest and the lowest % of value added in manufacturing in Greece?
Provide a short and direct response. 6.19. What is the difference between the highest and the lowest % of value added in manufacturing in Israel?
Provide a short and direct response. 5.39. 